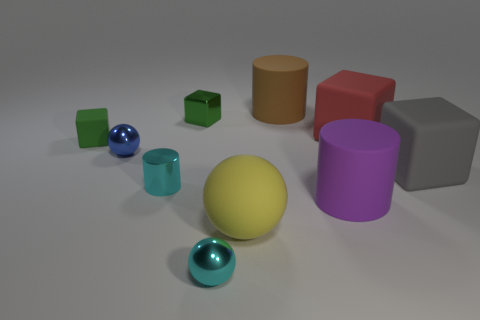What is the shape of the other small object that is the same color as the small rubber thing?
Ensure brevity in your answer.  Cube. Are the big brown thing and the large red block right of the shiny cube made of the same material?
Your answer should be very brief. Yes. How many small things are in front of the small ball that is behind the yellow ball that is in front of the gray block?
Offer a terse response. 2. How many green objects are matte blocks or tiny shiny spheres?
Provide a short and direct response. 1. What is the shape of the large object behind the red rubber object?
Provide a short and direct response. Cylinder. The ball that is the same size as the gray object is what color?
Your answer should be compact. Yellow. Does the big yellow matte object have the same shape as the tiny cyan metallic thing behind the big purple object?
Provide a succinct answer. No. What is the material of the tiny sphere behind the cyan thing that is in front of the large object in front of the purple rubber cylinder?
Provide a succinct answer. Metal. What number of small objects are either cylinders or gray blocks?
Offer a terse response. 1. How many other objects are the same size as the cyan cylinder?
Keep it short and to the point. 4. 